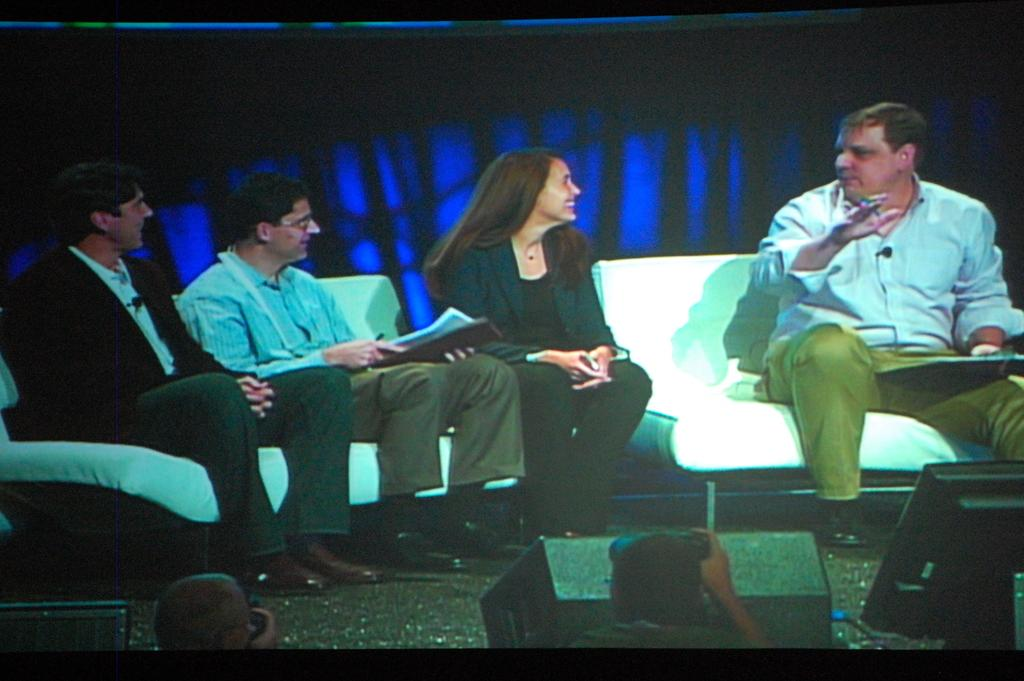How many people are in the image? There are four people in the image. What are the people doing in the image? Four people are sitting on sofas. Can you describe the man on the right side of the image? The man on the right side of the image is holding a pen and a notepad. What type of dog is sitting next to the man with the pen and notepad? There is no dog present in the image. 